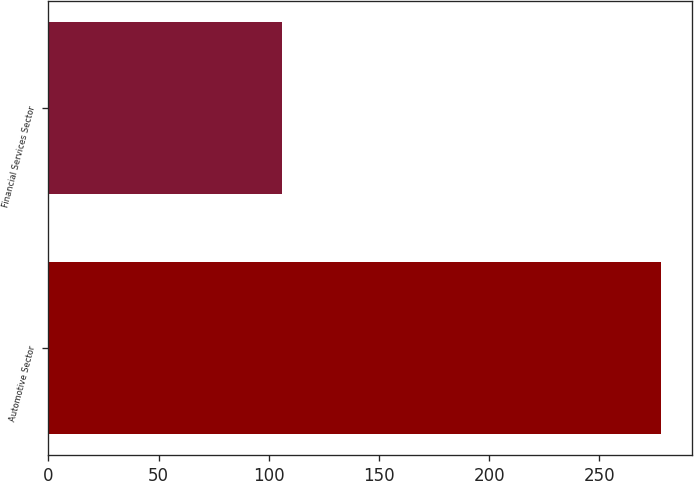Convert chart to OTSL. <chart><loc_0><loc_0><loc_500><loc_500><bar_chart><fcel>Automotive Sector<fcel>Financial Services Sector<nl><fcel>278<fcel>106<nl></chart> 